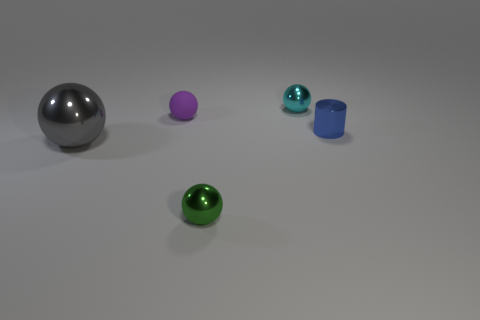Is there anything else that is the same size as the gray shiny ball?
Offer a terse response. No. What number of other things are there of the same shape as the blue shiny thing?
Keep it short and to the point. 0. There is a small rubber thing; what number of cylinders are in front of it?
Your response must be concise. 1. What is the tiny sphere that is behind the blue cylinder and in front of the cyan metallic object made of?
Give a very brief answer. Rubber. How many gray shiny balls have the same size as the cyan metal thing?
Your answer should be very brief. 0. What color is the small shiny sphere to the left of the tiny metal ball behind the green metallic ball?
Provide a short and direct response. Green. Are any big gray metal things visible?
Make the answer very short. Yes. Is the shape of the gray thing the same as the tiny matte object?
Keep it short and to the point. Yes. There is a small shiny ball behind the blue cylinder; how many tiny cyan shiny balls are left of it?
Ensure brevity in your answer.  0. What number of things are behind the large shiny sphere and right of the purple thing?
Offer a very short reply. 2. 